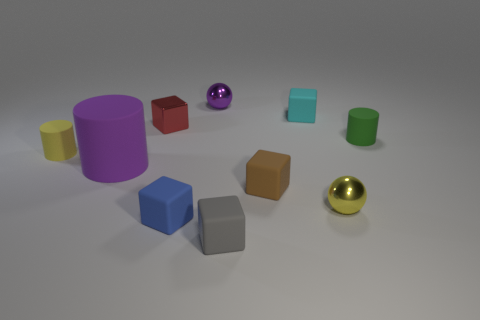There is a small sphere that is the same color as the big matte cylinder; what material is it?
Give a very brief answer. Metal. What number of things are either small rubber objects in front of the tiny green cylinder or purple rubber cylinders?
Your response must be concise. 5. There is a shiny sphere that is left of the tiny metal thing that is right of the tiny cyan rubber object; what number of shiny spheres are right of it?
Give a very brief answer. 1. Is there anything else that has the same size as the green matte cylinder?
Give a very brief answer. Yes. What shape is the small brown thing that is on the left side of the tiny rubber object that is right of the tiny rubber block to the right of the brown thing?
Offer a terse response. Cube. How many other objects are there of the same color as the metallic cube?
Keep it short and to the point. 0. What shape is the gray object that is in front of the green rubber cylinder to the right of the purple cylinder?
Make the answer very short. Cube. There is a purple cylinder; how many large matte objects are behind it?
Your answer should be very brief. 0. Are there any tiny gray cubes made of the same material as the purple ball?
Your answer should be compact. No. There is a brown cube that is the same size as the cyan rubber object; what material is it?
Make the answer very short. Rubber. 